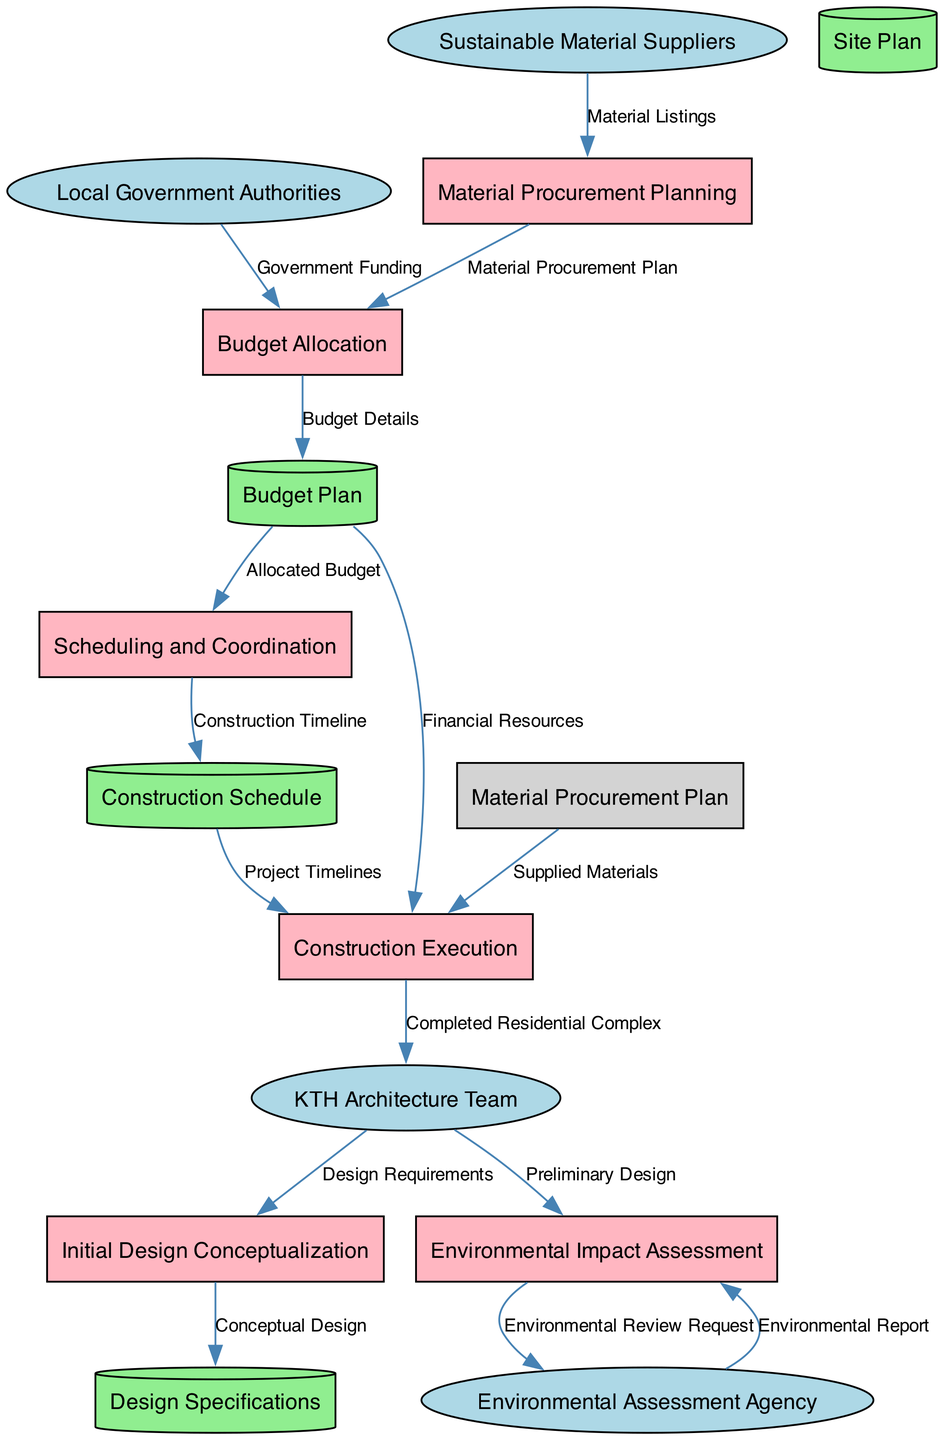What are the external entities involved in this process? The diagram shows four external entities: KTH Architecture Team, Environmental Assessment Agency, Sustainable Material Suppliers, and Local Government Authorities. These entities interact with processes and data stores in designing and constructing the residential complex.
Answer: KTH Architecture Team, Environmental Assessment Agency, Sustainable Material Suppliers, Local Government Authorities How many data stores are present in the diagram? The diagram indicates there are four data stores: Design Specifications, Site Plan, Budget Plan, and Construction Schedule. These stores are critical for managing data throughout the processes.
Answer: 4 Which process receives input from the KTH Architecture Team and the Local Government Authorities? The Budget Allocation process receives inputs from both the KTH Architecture Team and the Local Government Authorities. This step is essential for determining the financial support and resource management for the project.
Answer: Budget Allocation What is the output of the process "Material Procurement Planning"? The output of the Material Procurement Planning process is the Material Procurement Plan. This plan details the materials required, laying the groundwork for the subsequent budgeting and scheduling processes.
Answer: Material Procurement Plan What type of data flows from the Environmental Impact Assessment to the Environmental Assessment Agency? The data flow from the Environmental Impact Assessment to the Environmental Assessment Agency is labeled "Environmental Review Request." This flow indicates a request for a review to assess the environmental impact of the proposed designs.
Answer: Environmental Review Request How does the Construction Schedule connect to the Construction Execution process? The Construction Schedule is connected to the Construction Execution process via the data flow labeled "Project Timelines." This indicates that the execution of the construction depends on the timelines set in the schedule.
Answer: Project Timelines What are the inputs used in the initial design conceptualization process? The inputs for the Initial Design Conceptualization process are the KTH Architecture Team and the Site Plan. This combination is necessary to develop the first conceptual designs based on site conditions.
Answer: KTH Architecture Team, Site Plan Which data store is populated by the Budget Allocation process? The Budget Allocation process populates the Budget Plan data store. This store plays a crucial role in managing financial information for the project, which is essential for the scheduling and execution phases.
Answer: Budget Plan What two main inputs are required for the Scheduling and Coordination process? The main inputs required for the Scheduling and Coordination process are the Budget Plan and the Material Procurement Plan. These inputs allow for effective scheduling based on available resources and finances.
Answer: Budget Plan, Material Procurement Plan 